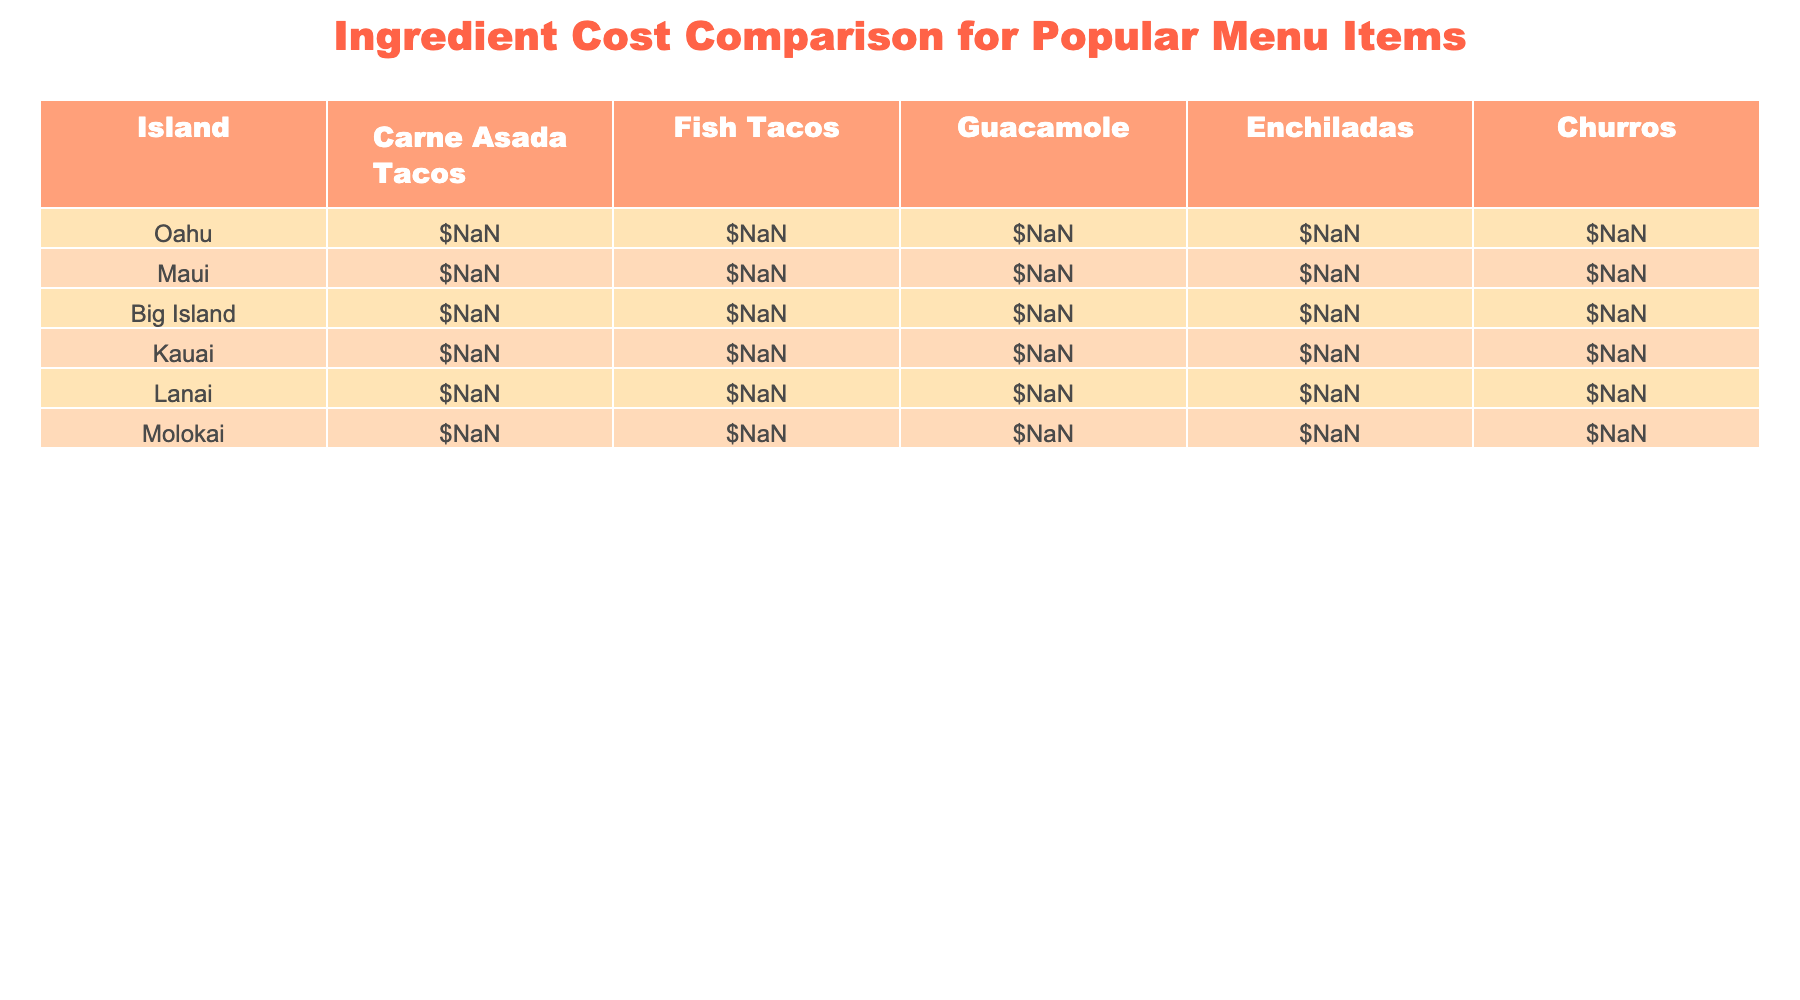What is the cost of Guacamole on Oahu? The table shows that the cost of Guacamole on Oahu is listed under the corresponding column, which is $3.80.
Answer: $3.80 Which island has the highest cost for Churros? By examining the Churros column, Lanai has the highest price listed at $2.60 compared to other islands.
Answer: Lanai What is the average cost of Fish Tacos across all islands? To find the average, add the costs of Fish Tacos from all islands: $5.20 + $4.90 + $5.50 + $5.10 + $5.40 + $5.30 = $31.60. There are six islands, so the average cost is $31.60 / 6 = $5.27.
Answer: $5.27 Is the cost of Enchiladas more than $6.00 on any island? Checking the Enchiladas column, the prices are $6.10 (Oahu), $6.50 (Maui), $6.30 (Kauai), and $6.70 (Lanai), all above $6.00.
Answer: Yes What is the difference in cost of Carne Asada Tacos between the highest and lowest priced island? The highest cost for Carne Asada Tacos is $5.10 (Lanai) and the lowest is $4.30 (Big Island). The difference is $5.10 - $4.30 = $0.80.
Answer: $0.80 Which island has the most expensive Guacamole? By looking at the Guacamole column, Maui has the highest price at $4.10 compared to the other islands.
Answer: Maui If I wanted to purchase one of each menu item from Kauai, what would the total cost be? From the Kauai row: Carne Asada Tacos ($4.70) + Fish Tacos ($5.10) + Guacamole ($4.00) + Enchiladas ($6.30) + Churros ($2.40) = $22.50 total.
Answer: $22.50 How many menu items cost less than $5.00 across all islands? By examining each menu item, Churros from all islands cost less than $5.00, while Guacamole has prices at or above $3.60. Only the costs of Carne Asada Tacos and Fish Tacos from certain islands fall under $5.00. The total number of items below $5.00 is 8.
Answer: 8 Is the average cost of Carne Asada Tacos on Maui higher or lower than the overall average? To determine the overall average of Carne Asada Tacos ($4.50 for Oahu, $4.80 for Maui, $4.30 for Big Island, $4.70 for Kauai, $5.10 for Lanai, $4.90 for Molokai), sum these up ($4.50 + $4.80 + $4.30 + $4.70 + $5.10 + $4.90 = $28.30) and divide by 6, which results in $4.72. Since Maui's cost is $4.80, it is higher than the average.
Answer: Higher Which island has the least variation in the cost of Fish Tacos? To find the variation, look at the range of Fish Taco prices: $5.50 (Big Island) to $4.90 (Maui) results in a range of $0.60, while differences among islands suggest Molokai's $5.30 is quite close to its $0.30 range, making it the island with the least variation.
Answer: Molokai 